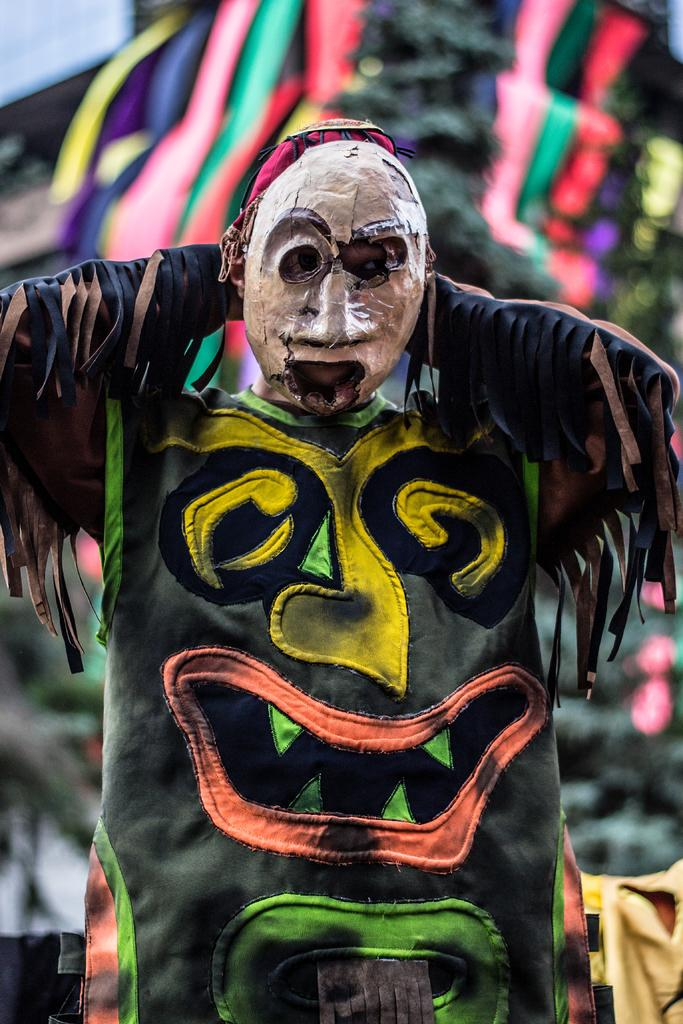Who is present in the image? There is a man in the image. What is the man wearing? The man is wearing a costume. What can be seen in the background of the image? There are clothes visible in the background of the image. What type of board is the man using to perform tricks in the image? There is no board present in the image; the man is wearing a costume. Can you describe the garden where the man is performing in the image? There is no garden present in the image; the man is wearing a costume and there are clothes visible in the background. 